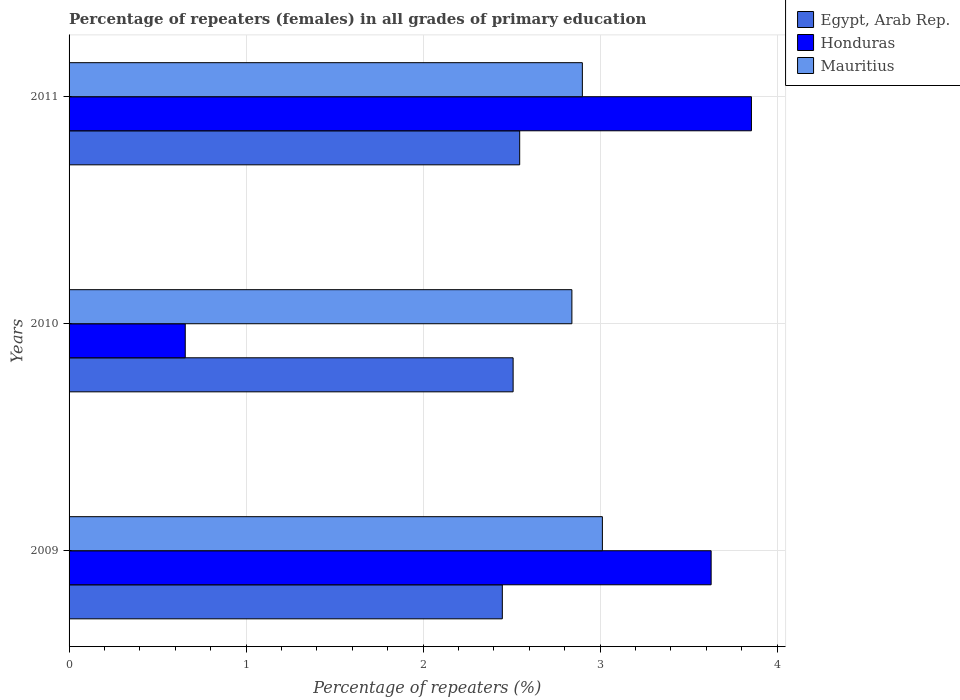How many different coloured bars are there?
Provide a short and direct response. 3. How many groups of bars are there?
Provide a succinct answer. 3. Are the number of bars on each tick of the Y-axis equal?
Offer a very short reply. Yes. How many bars are there on the 2nd tick from the top?
Offer a terse response. 3. How many bars are there on the 1st tick from the bottom?
Give a very brief answer. 3. What is the label of the 1st group of bars from the top?
Ensure brevity in your answer.  2011. In how many cases, is the number of bars for a given year not equal to the number of legend labels?
Offer a terse response. 0. What is the percentage of repeaters (females) in Honduras in 2009?
Offer a terse response. 3.63. Across all years, what is the maximum percentage of repeaters (females) in Egypt, Arab Rep.?
Offer a very short reply. 2.55. Across all years, what is the minimum percentage of repeaters (females) in Mauritius?
Ensure brevity in your answer.  2.84. In which year was the percentage of repeaters (females) in Honduras maximum?
Your answer should be very brief. 2011. In which year was the percentage of repeaters (females) in Honduras minimum?
Your answer should be very brief. 2010. What is the total percentage of repeaters (females) in Mauritius in the graph?
Make the answer very short. 8.75. What is the difference between the percentage of repeaters (females) in Egypt, Arab Rep. in 2009 and that in 2010?
Your response must be concise. -0.06. What is the difference between the percentage of repeaters (females) in Mauritius in 2010 and the percentage of repeaters (females) in Honduras in 2009?
Provide a succinct answer. -0.79. What is the average percentage of repeaters (females) in Honduras per year?
Make the answer very short. 2.71. In the year 2010, what is the difference between the percentage of repeaters (females) in Mauritius and percentage of repeaters (females) in Egypt, Arab Rep.?
Offer a terse response. 0.33. What is the ratio of the percentage of repeaters (females) in Mauritius in 2010 to that in 2011?
Your response must be concise. 0.98. Is the percentage of repeaters (females) in Egypt, Arab Rep. in 2010 less than that in 2011?
Make the answer very short. Yes. What is the difference between the highest and the second highest percentage of repeaters (females) in Honduras?
Offer a terse response. 0.23. What is the difference between the highest and the lowest percentage of repeaters (females) in Mauritius?
Ensure brevity in your answer.  0.17. Is the sum of the percentage of repeaters (females) in Honduras in 2009 and 2010 greater than the maximum percentage of repeaters (females) in Mauritius across all years?
Your answer should be very brief. Yes. What does the 2nd bar from the top in 2009 represents?
Offer a terse response. Honduras. What does the 2nd bar from the bottom in 2009 represents?
Offer a very short reply. Honduras. How many bars are there?
Make the answer very short. 9. Are all the bars in the graph horizontal?
Your answer should be very brief. Yes. How many years are there in the graph?
Keep it short and to the point. 3. Are the values on the major ticks of X-axis written in scientific E-notation?
Keep it short and to the point. No. How are the legend labels stacked?
Keep it short and to the point. Vertical. What is the title of the graph?
Offer a terse response. Percentage of repeaters (females) in all grades of primary education. What is the label or title of the X-axis?
Provide a short and direct response. Percentage of repeaters (%). What is the Percentage of repeaters (%) in Egypt, Arab Rep. in 2009?
Make the answer very short. 2.45. What is the Percentage of repeaters (%) of Honduras in 2009?
Give a very brief answer. 3.63. What is the Percentage of repeaters (%) of Mauritius in 2009?
Provide a succinct answer. 3.01. What is the Percentage of repeaters (%) in Egypt, Arab Rep. in 2010?
Make the answer very short. 2.51. What is the Percentage of repeaters (%) of Honduras in 2010?
Give a very brief answer. 0.66. What is the Percentage of repeaters (%) of Mauritius in 2010?
Your answer should be compact. 2.84. What is the Percentage of repeaters (%) of Egypt, Arab Rep. in 2011?
Your response must be concise. 2.55. What is the Percentage of repeaters (%) of Honduras in 2011?
Your response must be concise. 3.86. What is the Percentage of repeaters (%) of Mauritius in 2011?
Your answer should be compact. 2.9. Across all years, what is the maximum Percentage of repeaters (%) of Egypt, Arab Rep.?
Your answer should be very brief. 2.55. Across all years, what is the maximum Percentage of repeaters (%) of Honduras?
Your response must be concise. 3.86. Across all years, what is the maximum Percentage of repeaters (%) in Mauritius?
Offer a terse response. 3.01. Across all years, what is the minimum Percentage of repeaters (%) in Egypt, Arab Rep.?
Keep it short and to the point. 2.45. Across all years, what is the minimum Percentage of repeaters (%) of Honduras?
Provide a succinct answer. 0.66. Across all years, what is the minimum Percentage of repeaters (%) of Mauritius?
Offer a very short reply. 2.84. What is the total Percentage of repeaters (%) in Egypt, Arab Rep. in the graph?
Give a very brief answer. 7.5. What is the total Percentage of repeaters (%) of Honduras in the graph?
Give a very brief answer. 8.14. What is the total Percentage of repeaters (%) of Mauritius in the graph?
Give a very brief answer. 8.75. What is the difference between the Percentage of repeaters (%) of Egypt, Arab Rep. in 2009 and that in 2010?
Make the answer very short. -0.06. What is the difference between the Percentage of repeaters (%) in Honduras in 2009 and that in 2010?
Give a very brief answer. 2.97. What is the difference between the Percentage of repeaters (%) of Mauritius in 2009 and that in 2010?
Offer a very short reply. 0.17. What is the difference between the Percentage of repeaters (%) in Egypt, Arab Rep. in 2009 and that in 2011?
Provide a short and direct response. -0.1. What is the difference between the Percentage of repeaters (%) of Honduras in 2009 and that in 2011?
Provide a succinct answer. -0.23. What is the difference between the Percentage of repeaters (%) of Mauritius in 2009 and that in 2011?
Provide a short and direct response. 0.11. What is the difference between the Percentage of repeaters (%) in Egypt, Arab Rep. in 2010 and that in 2011?
Make the answer very short. -0.04. What is the difference between the Percentage of repeaters (%) of Honduras in 2010 and that in 2011?
Your answer should be very brief. -3.2. What is the difference between the Percentage of repeaters (%) of Mauritius in 2010 and that in 2011?
Provide a short and direct response. -0.06. What is the difference between the Percentage of repeaters (%) in Egypt, Arab Rep. in 2009 and the Percentage of repeaters (%) in Honduras in 2010?
Your response must be concise. 1.79. What is the difference between the Percentage of repeaters (%) in Egypt, Arab Rep. in 2009 and the Percentage of repeaters (%) in Mauritius in 2010?
Offer a very short reply. -0.39. What is the difference between the Percentage of repeaters (%) of Honduras in 2009 and the Percentage of repeaters (%) of Mauritius in 2010?
Give a very brief answer. 0.79. What is the difference between the Percentage of repeaters (%) of Egypt, Arab Rep. in 2009 and the Percentage of repeaters (%) of Honduras in 2011?
Give a very brief answer. -1.41. What is the difference between the Percentage of repeaters (%) of Egypt, Arab Rep. in 2009 and the Percentage of repeaters (%) of Mauritius in 2011?
Your response must be concise. -0.45. What is the difference between the Percentage of repeaters (%) of Honduras in 2009 and the Percentage of repeaters (%) of Mauritius in 2011?
Your answer should be compact. 0.73. What is the difference between the Percentage of repeaters (%) of Egypt, Arab Rep. in 2010 and the Percentage of repeaters (%) of Honduras in 2011?
Give a very brief answer. -1.35. What is the difference between the Percentage of repeaters (%) in Egypt, Arab Rep. in 2010 and the Percentage of repeaters (%) in Mauritius in 2011?
Provide a short and direct response. -0.39. What is the difference between the Percentage of repeaters (%) of Honduras in 2010 and the Percentage of repeaters (%) of Mauritius in 2011?
Your answer should be compact. -2.24. What is the average Percentage of repeaters (%) in Egypt, Arab Rep. per year?
Your answer should be very brief. 2.5. What is the average Percentage of repeaters (%) in Honduras per year?
Your answer should be compact. 2.71. What is the average Percentage of repeaters (%) in Mauritius per year?
Offer a terse response. 2.92. In the year 2009, what is the difference between the Percentage of repeaters (%) of Egypt, Arab Rep. and Percentage of repeaters (%) of Honduras?
Offer a very short reply. -1.18. In the year 2009, what is the difference between the Percentage of repeaters (%) of Egypt, Arab Rep. and Percentage of repeaters (%) of Mauritius?
Make the answer very short. -0.57. In the year 2009, what is the difference between the Percentage of repeaters (%) of Honduras and Percentage of repeaters (%) of Mauritius?
Give a very brief answer. 0.61. In the year 2010, what is the difference between the Percentage of repeaters (%) in Egypt, Arab Rep. and Percentage of repeaters (%) in Honduras?
Keep it short and to the point. 1.85. In the year 2010, what is the difference between the Percentage of repeaters (%) in Egypt, Arab Rep. and Percentage of repeaters (%) in Mauritius?
Your answer should be very brief. -0.33. In the year 2010, what is the difference between the Percentage of repeaters (%) in Honduras and Percentage of repeaters (%) in Mauritius?
Keep it short and to the point. -2.18. In the year 2011, what is the difference between the Percentage of repeaters (%) in Egypt, Arab Rep. and Percentage of repeaters (%) in Honduras?
Your answer should be very brief. -1.31. In the year 2011, what is the difference between the Percentage of repeaters (%) in Egypt, Arab Rep. and Percentage of repeaters (%) in Mauritius?
Make the answer very short. -0.35. In the year 2011, what is the difference between the Percentage of repeaters (%) of Honduras and Percentage of repeaters (%) of Mauritius?
Your answer should be very brief. 0.96. What is the ratio of the Percentage of repeaters (%) of Egypt, Arab Rep. in 2009 to that in 2010?
Ensure brevity in your answer.  0.98. What is the ratio of the Percentage of repeaters (%) of Honduras in 2009 to that in 2010?
Give a very brief answer. 5.53. What is the ratio of the Percentage of repeaters (%) in Mauritius in 2009 to that in 2010?
Provide a short and direct response. 1.06. What is the ratio of the Percentage of repeaters (%) of Egypt, Arab Rep. in 2009 to that in 2011?
Provide a short and direct response. 0.96. What is the ratio of the Percentage of repeaters (%) of Honduras in 2009 to that in 2011?
Make the answer very short. 0.94. What is the ratio of the Percentage of repeaters (%) in Mauritius in 2009 to that in 2011?
Make the answer very short. 1.04. What is the ratio of the Percentage of repeaters (%) in Egypt, Arab Rep. in 2010 to that in 2011?
Provide a succinct answer. 0.99. What is the ratio of the Percentage of repeaters (%) of Honduras in 2010 to that in 2011?
Ensure brevity in your answer.  0.17. What is the ratio of the Percentage of repeaters (%) of Mauritius in 2010 to that in 2011?
Your response must be concise. 0.98. What is the difference between the highest and the second highest Percentage of repeaters (%) of Egypt, Arab Rep.?
Your response must be concise. 0.04. What is the difference between the highest and the second highest Percentage of repeaters (%) in Honduras?
Provide a succinct answer. 0.23. What is the difference between the highest and the second highest Percentage of repeaters (%) of Mauritius?
Give a very brief answer. 0.11. What is the difference between the highest and the lowest Percentage of repeaters (%) in Egypt, Arab Rep.?
Keep it short and to the point. 0.1. What is the difference between the highest and the lowest Percentage of repeaters (%) of Honduras?
Ensure brevity in your answer.  3.2. What is the difference between the highest and the lowest Percentage of repeaters (%) in Mauritius?
Keep it short and to the point. 0.17. 